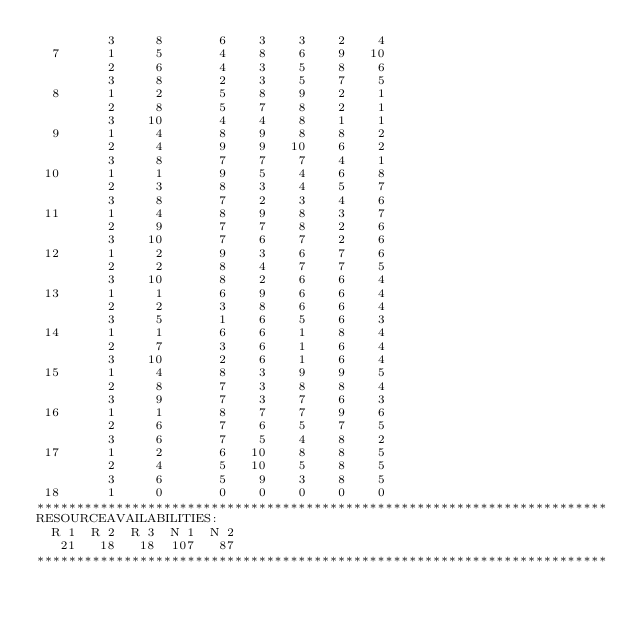Convert code to text. <code><loc_0><loc_0><loc_500><loc_500><_ObjectiveC_>         3     8       6    3    3    2    4
  7      1     5       4    8    6    9   10
         2     6       4    3    5    8    6
         3     8       2    3    5    7    5
  8      1     2       5    8    9    2    1
         2     8       5    7    8    2    1
         3    10       4    4    8    1    1
  9      1     4       8    9    8    8    2
         2     4       9    9   10    6    2
         3     8       7    7    7    4    1
 10      1     1       9    5    4    6    8
         2     3       8    3    4    5    7
         3     8       7    2    3    4    6
 11      1     4       8    9    8    3    7
         2     9       7    7    8    2    6
         3    10       7    6    7    2    6
 12      1     2       9    3    6    7    6
         2     2       8    4    7    7    5
         3    10       8    2    6    6    4
 13      1     1       6    9    6    6    4
         2     2       3    8    6    6    4
         3     5       1    6    5    6    3
 14      1     1       6    6    1    8    4
         2     7       3    6    1    6    4
         3    10       2    6    1    6    4
 15      1     4       8    3    9    9    5
         2     8       7    3    8    8    4
         3     9       7    3    7    6    3
 16      1     1       8    7    7    9    6
         2     6       7    6    5    7    5
         3     6       7    5    4    8    2
 17      1     2       6   10    8    8    5
         2     4       5   10    5    8    5
         3     6       5    9    3    8    5
 18      1     0       0    0    0    0    0
************************************************************************
RESOURCEAVAILABILITIES:
  R 1  R 2  R 3  N 1  N 2
   21   18   18  107   87
************************************************************************
</code> 